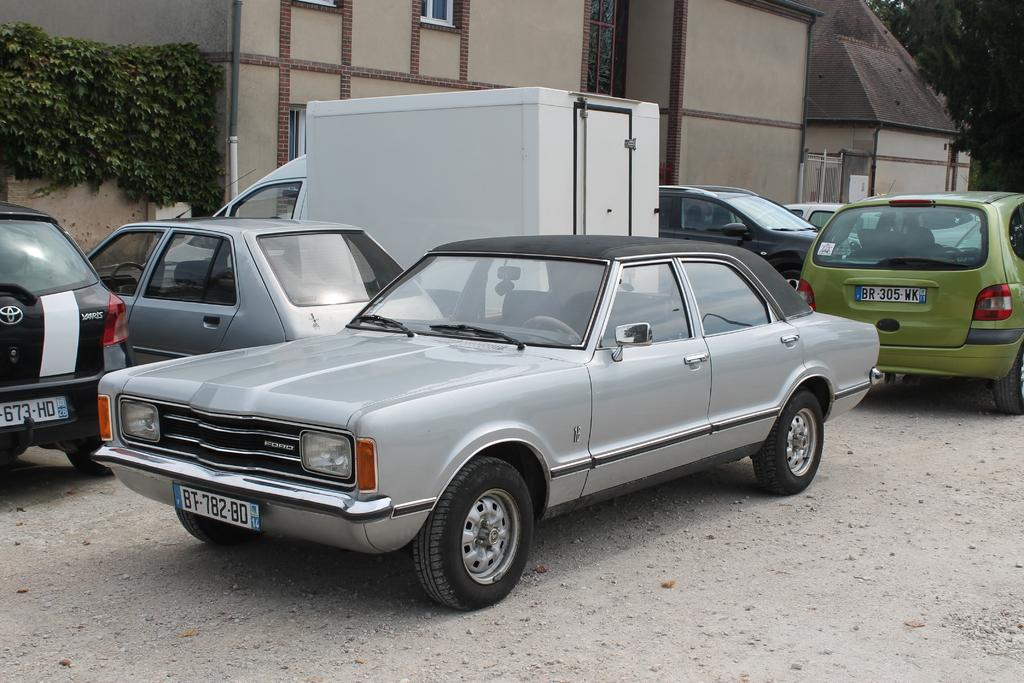What is happening on the road in the image? There are vehicles on the road in the image. What type of structures can be seen in the image? There are buildings in the image. What can be seen through the windows in the image? Windows are visible in the image, but we cannot see through them. What type of vegetation is present in the image? There are trees in the image. What are the poles used for in the image? The purpose of the poles in the image is not clear, but they could be for streetlights, signs, or other utilities. What type of cabbage is being grown in the image? There is no cabbage present in the image. What is the relationship between the vehicles and the buildings in the image? The relationship between the vehicles and the buildings in the image is not clear, but they coexist in the same environment. Which company is responsible for maintaining the trees in the image? The image does not provide information about the company responsible for maintaining the trees. 